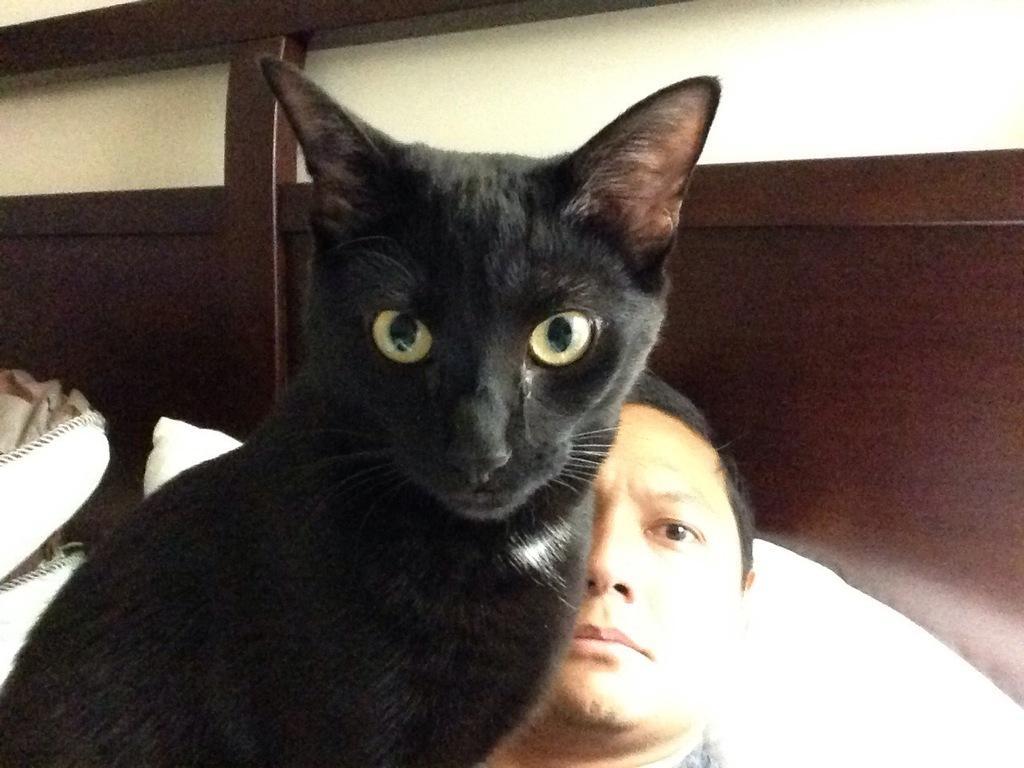How would you summarize this image in a sentence or two? In this picture we can see a black color cat and a man. 